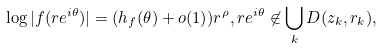<formula> <loc_0><loc_0><loc_500><loc_500>\log | f ( r e ^ { i \theta } ) | = ( h _ { f } ( \theta ) + o ( 1 ) ) r ^ { \rho } , r e ^ { i \theta } \not \in \bigcup _ { k } D ( z _ { k } , r _ { k } ) ,</formula> 